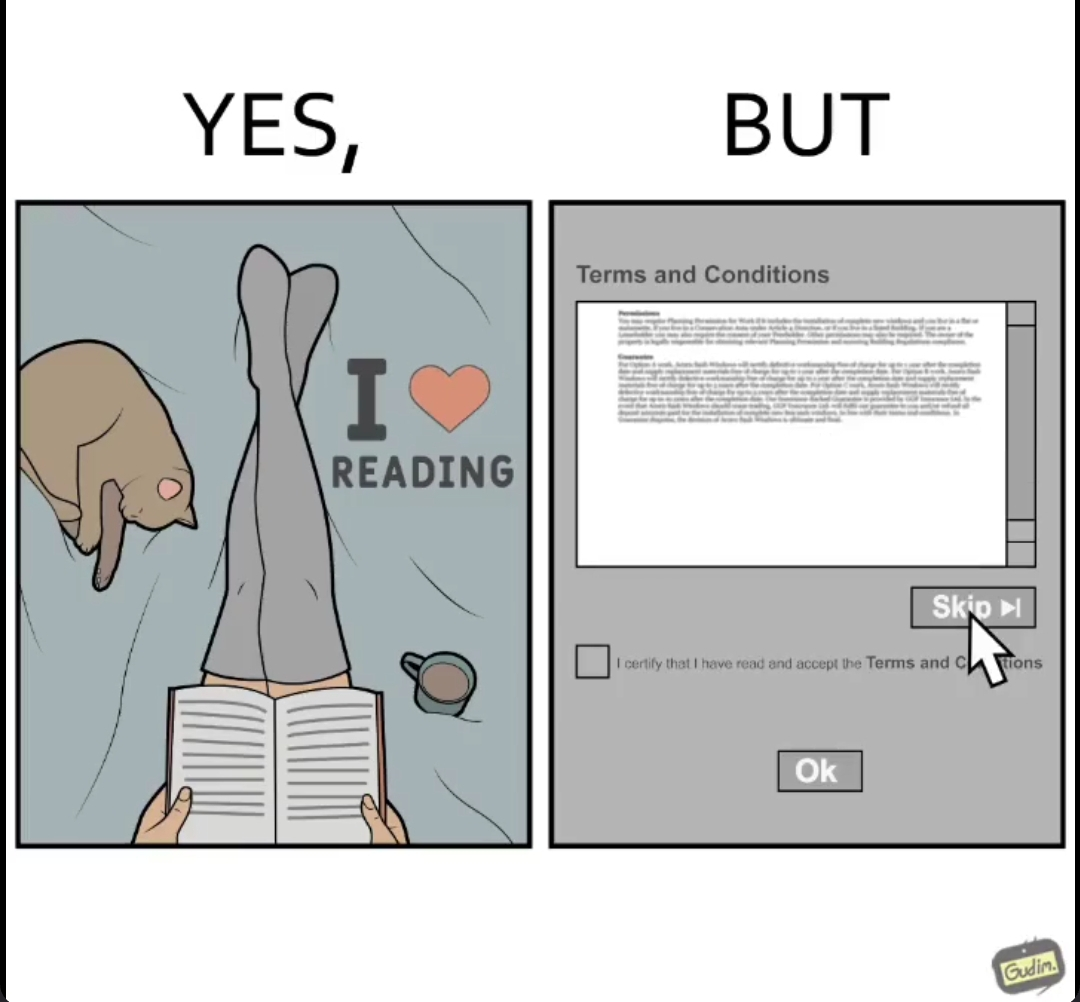What is shown in this image? the irony in this image is that people say that they like to read things while they instantly skip reading the terms and conditions when registering for anything online. 